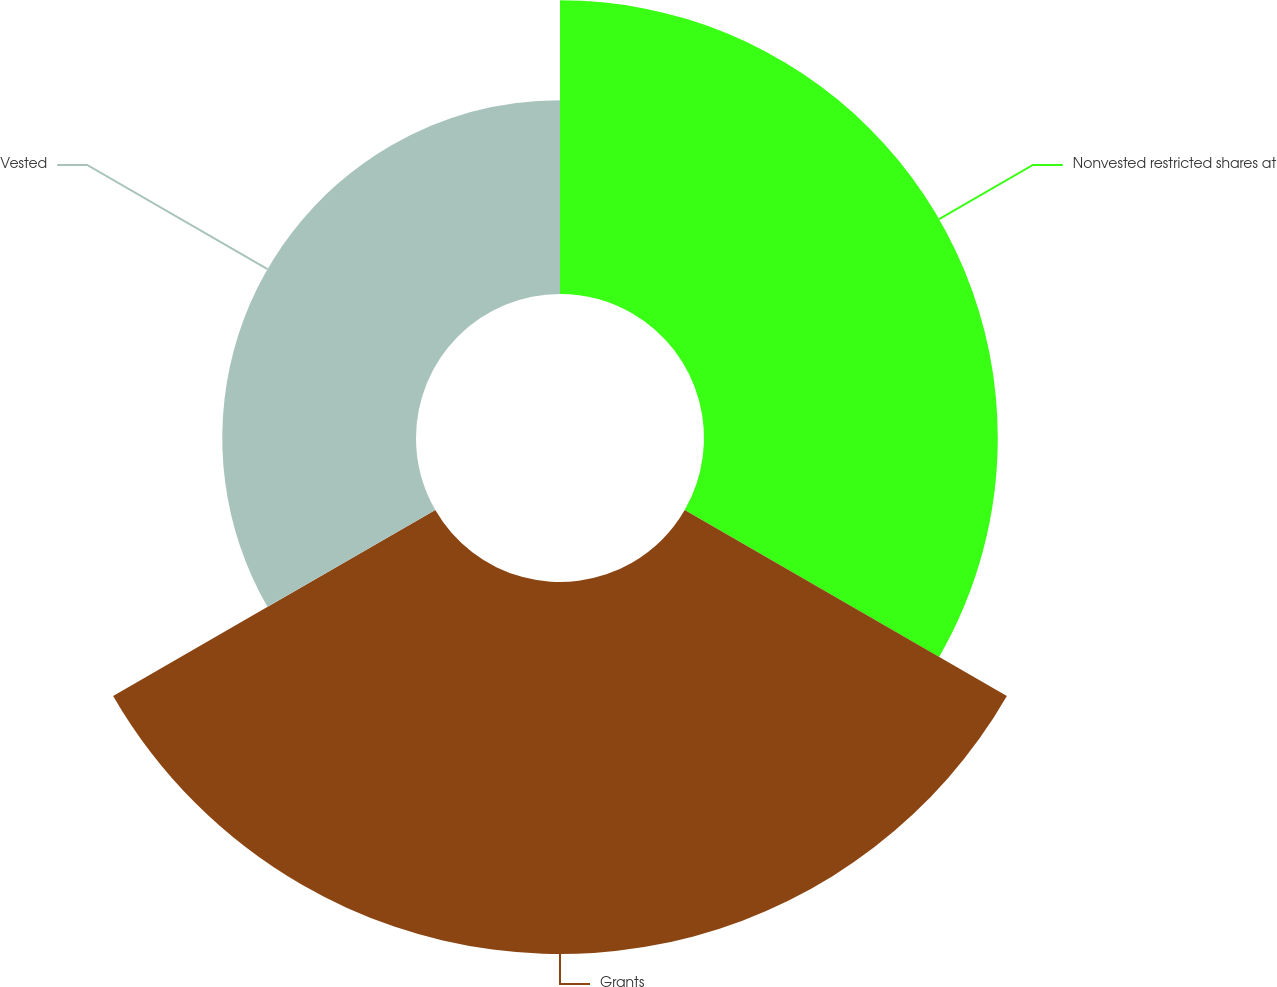Convert chart. <chart><loc_0><loc_0><loc_500><loc_500><pie_chart><fcel>Nonvested restricted shares at<fcel>Grants<fcel>Vested<nl><fcel>34.18%<fcel>43.28%<fcel>22.54%<nl></chart> 